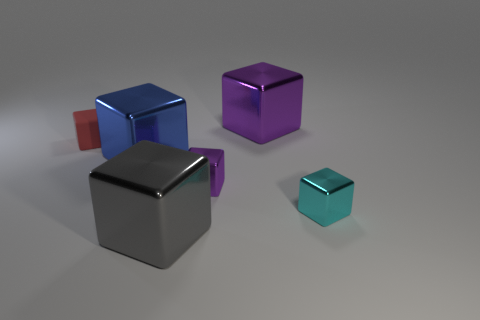Is there any other thing that is the same material as the tiny red object?
Your answer should be compact. No. Does the big object that is to the left of the gray cube have the same material as the red object?
Your response must be concise. No. The thing that is both in front of the small purple metal object and left of the cyan block has what shape?
Ensure brevity in your answer.  Cube. There is a large shiny thing in front of the large blue object; is there a tiny rubber block behind it?
Provide a succinct answer. Yes. How many other objects are the same material as the blue thing?
Your answer should be very brief. 4. There is a big object that is behind the red rubber cube; is its shape the same as the tiny object left of the large blue metallic cube?
Offer a very short reply. Yes. Is the big gray cube made of the same material as the small red object?
Keep it short and to the point. No. There is a metallic object on the left side of the thing in front of the tiny cube that is in front of the tiny purple metallic cube; what size is it?
Your answer should be compact. Large. What number of other objects are the same color as the small rubber block?
Ensure brevity in your answer.  0. There is a gray shiny object that is the same size as the blue thing; what shape is it?
Give a very brief answer. Cube. 